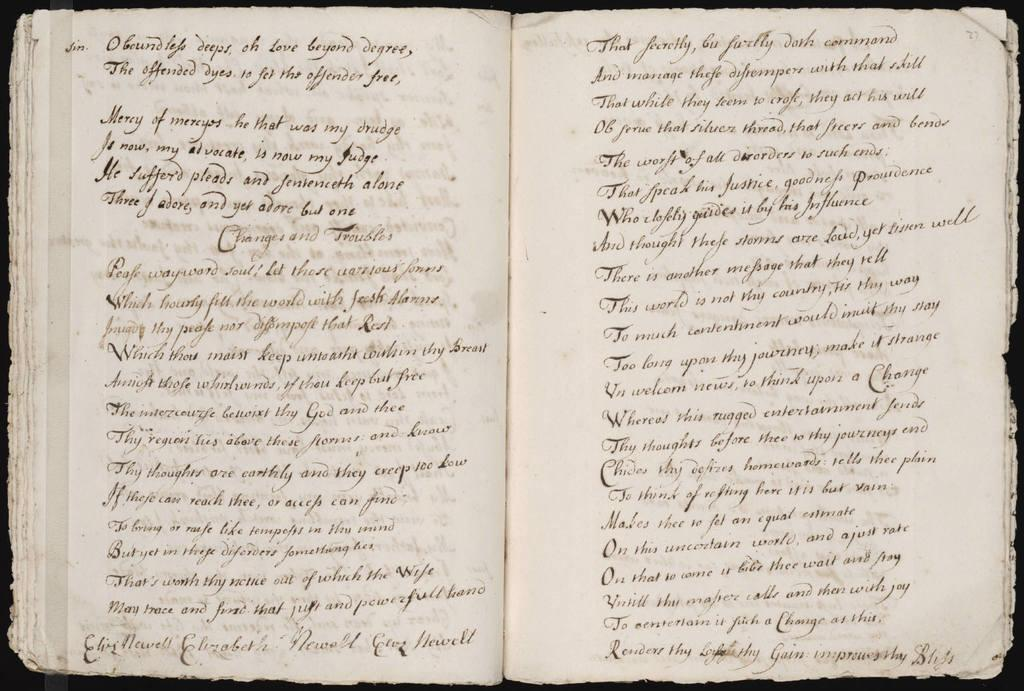What is the main subject of the image? The main subject of the image is a book. What can be seen on the pages of the book in the image? There are black color text lines visible in the image. What is the color of the borders surrounding the image? The image has black borders. What type of cap is the book wearing in the image? There is no cap present in the image, as books do not wear caps. Does the existence of the book in the image prove the existence of the author? The existence of the book in the image does not prove the existence of the author, as the author's identity is not mentioned or depicted in the image. 